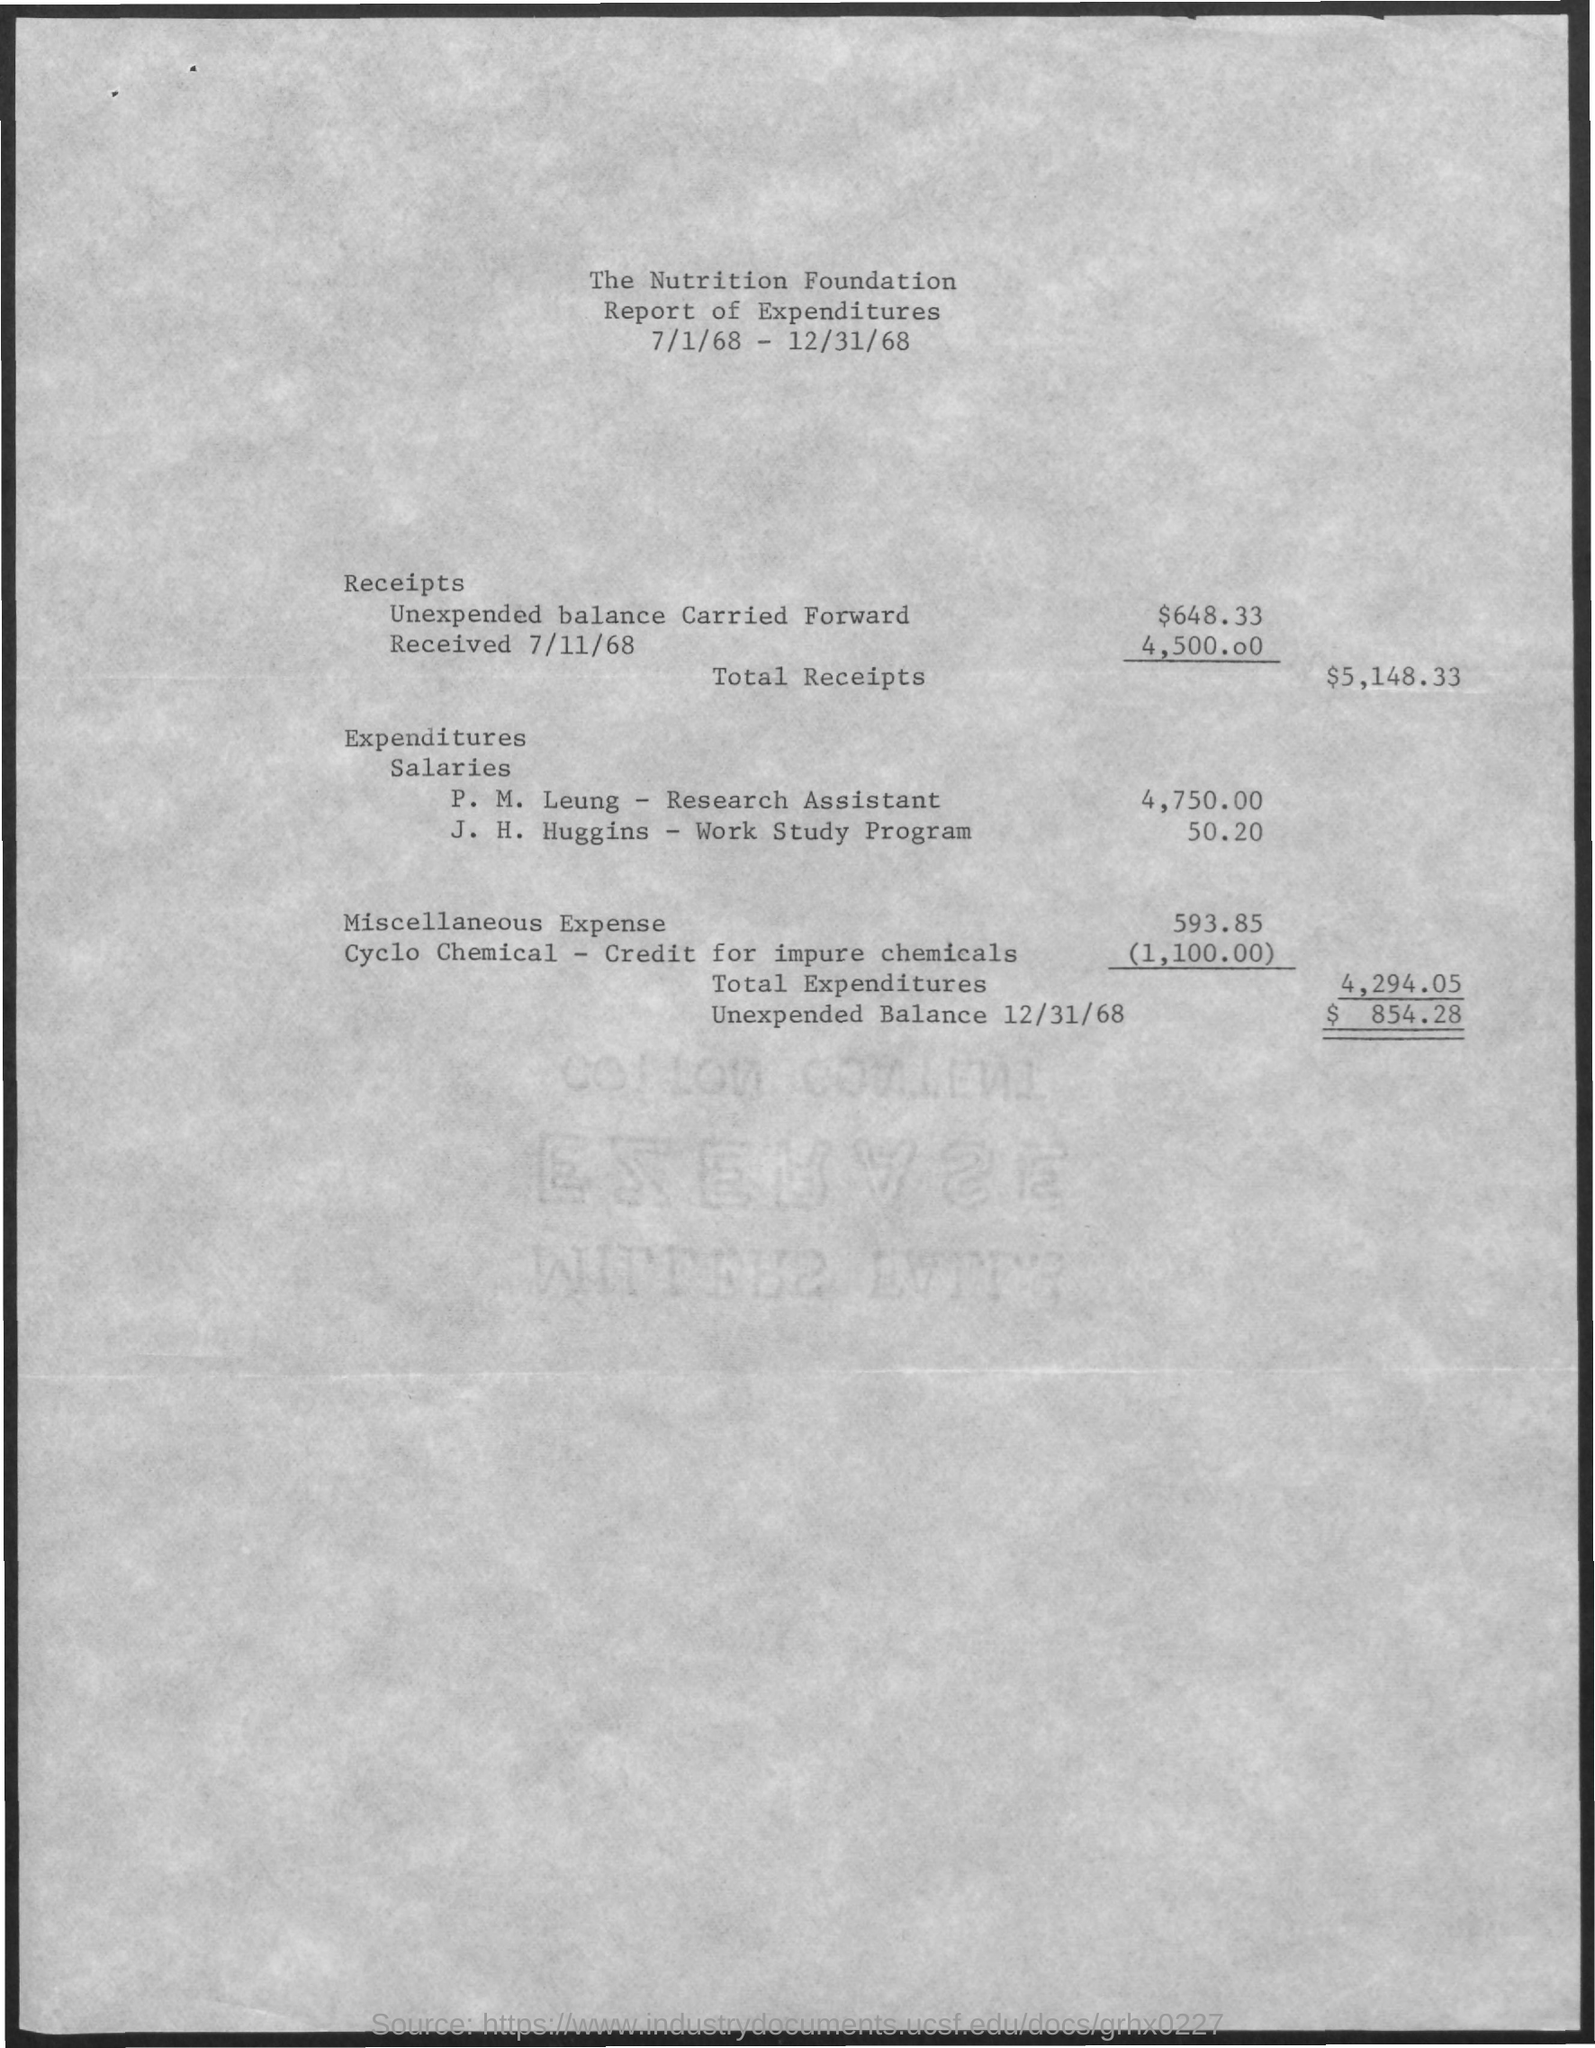Specify some key components in this picture. The salary given to P.M. Leung, a research assistant, is 4,750.00. The amount of unexpended balance carried forward, as shown in the report, is $648.33. The report mentions a total amount of $5,148.33 in receipts. As indicated in the report, the unexpended balance on December 31, 1968 was $854.28. On 7/11/68, the report shows that $4,500.00 was received. 